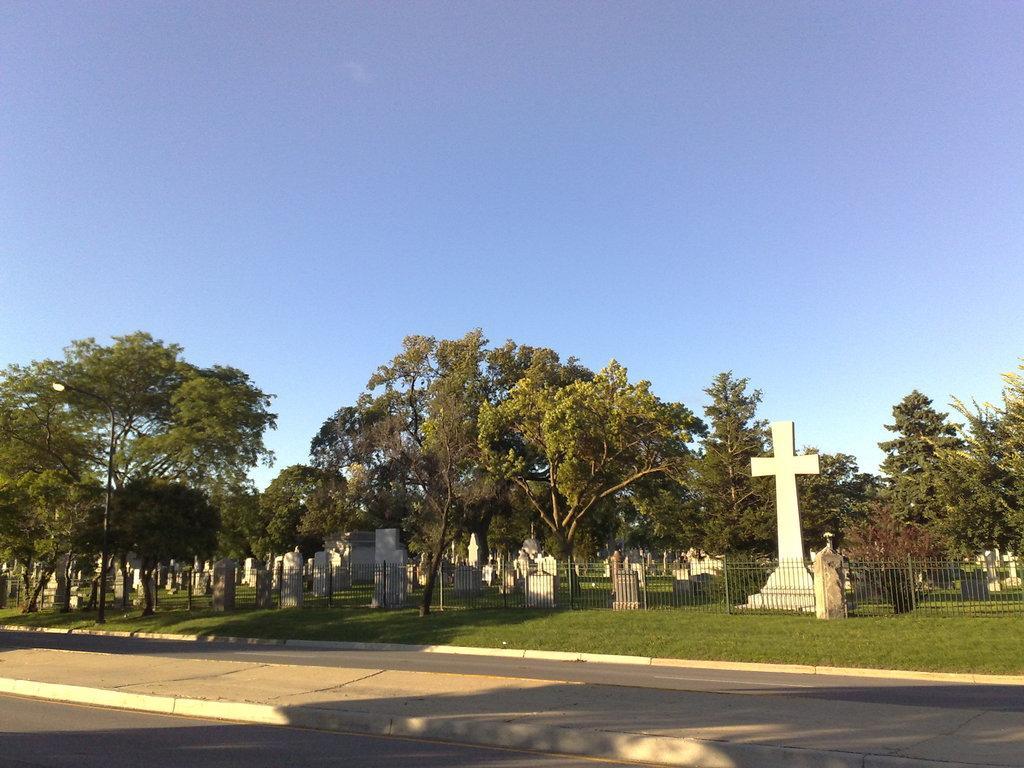How would you summarize this image in a sentence or two? In this picture I can see some cemeteries in one place, around the place we can see the fencing, trees, grass and also we can see the road. 